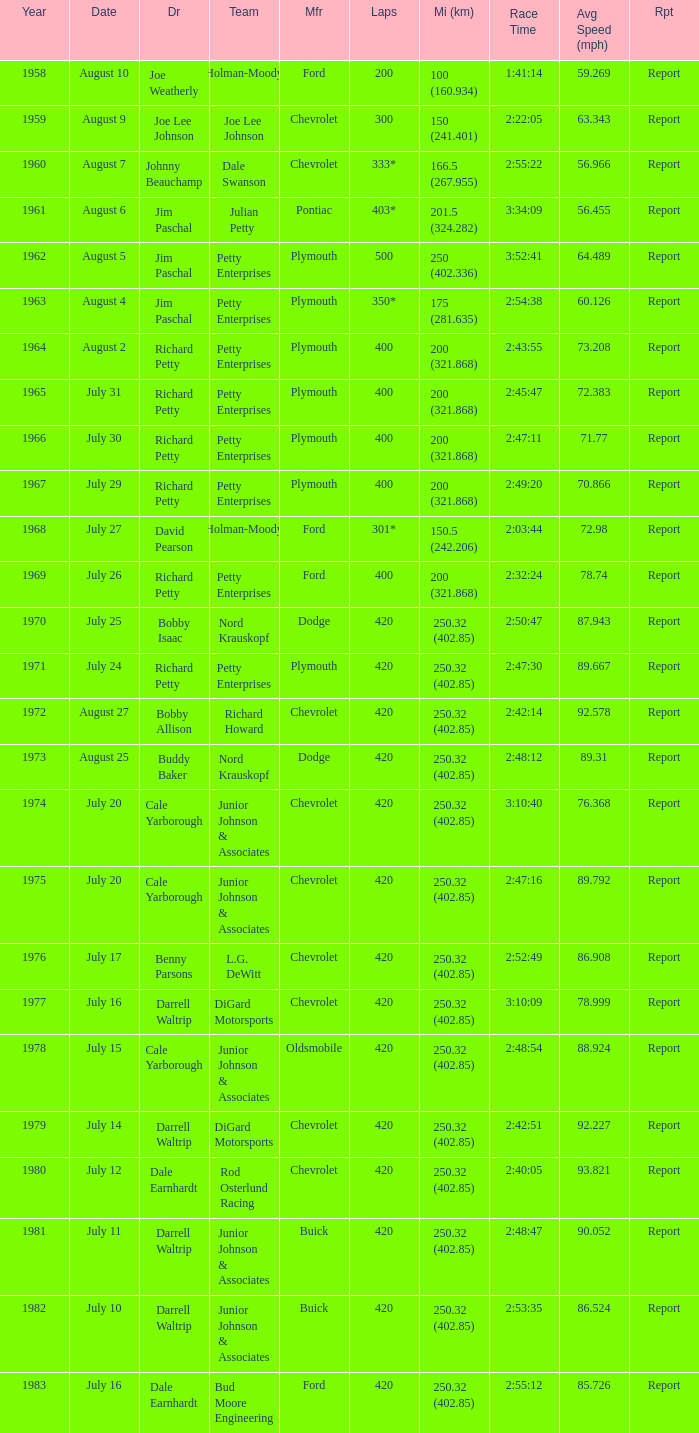Which year featured a race with 301 laps? 1968.0. 